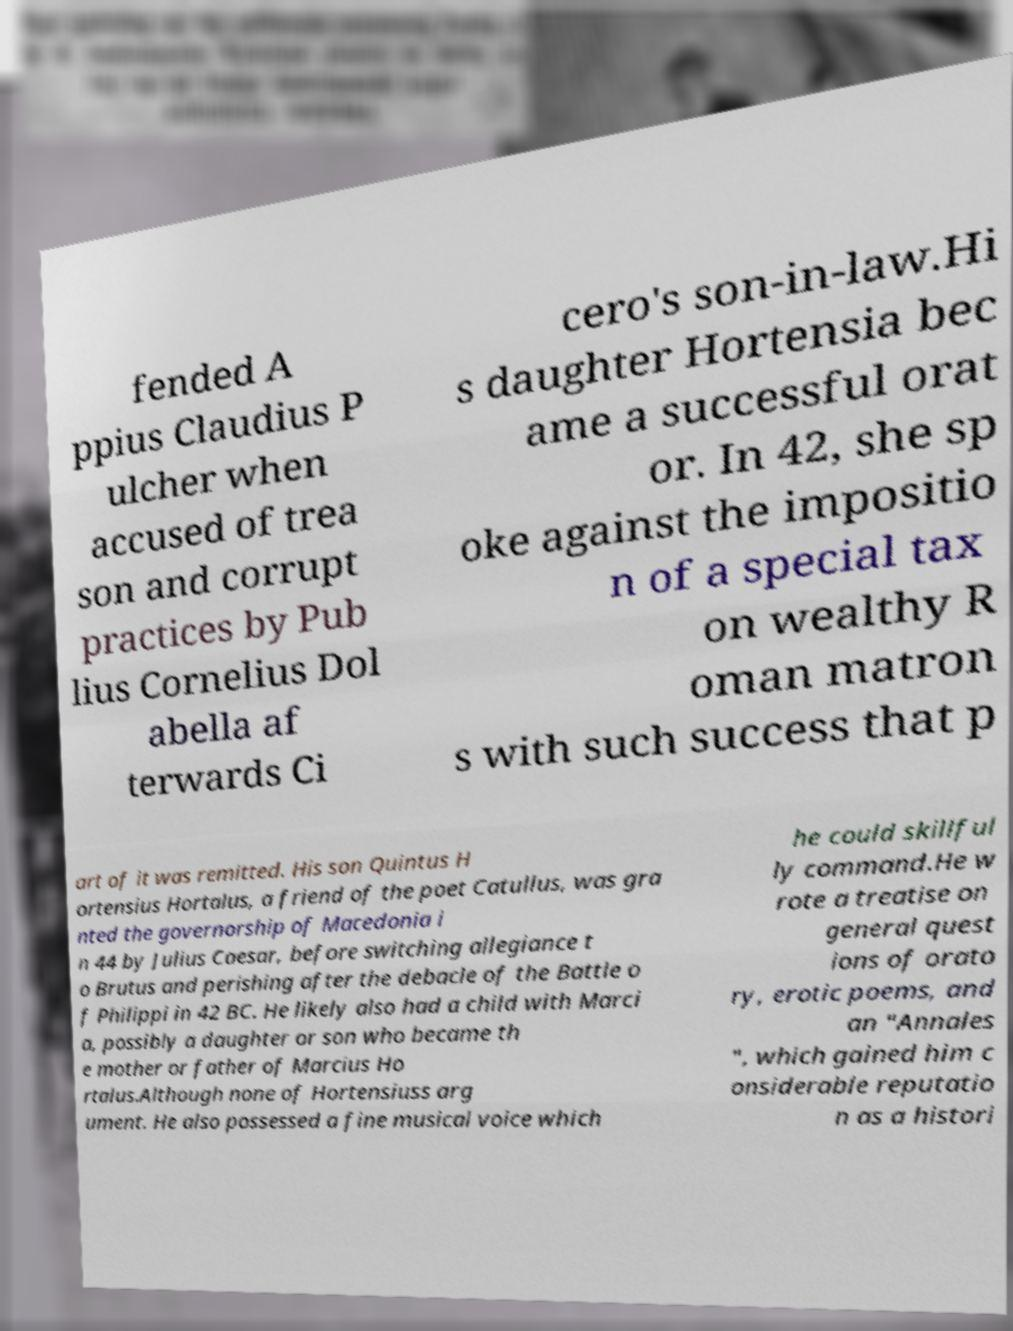Can you read and provide the text displayed in the image?This photo seems to have some interesting text. Can you extract and type it out for me? fended A ppius Claudius P ulcher when accused of trea son and corrupt practices by Pub lius Cornelius Dol abella af terwards Ci cero's son-in-law.Hi s daughter Hortensia bec ame a successful orat or. In 42, she sp oke against the impositio n of a special tax on wealthy R oman matron s with such success that p art of it was remitted. His son Quintus H ortensius Hortalus, a friend of the poet Catullus, was gra nted the governorship of Macedonia i n 44 by Julius Caesar, before switching allegiance t o Brutus and perishing after the debacle of the Battle o f Philippi in 42 BC. He likely also had a child with Marci a, possibly a daughter or son who became th e mother or father of Marcius Ho rtalus.Although none of Hortensiuss arg ument. He also possessed a fine musical voice which he could skillful ly command.He w rote a treatise on general quest ions of orato ry, erotic poems, and an "Annales ", which gained him c onsiderable reputatio n as a histori 